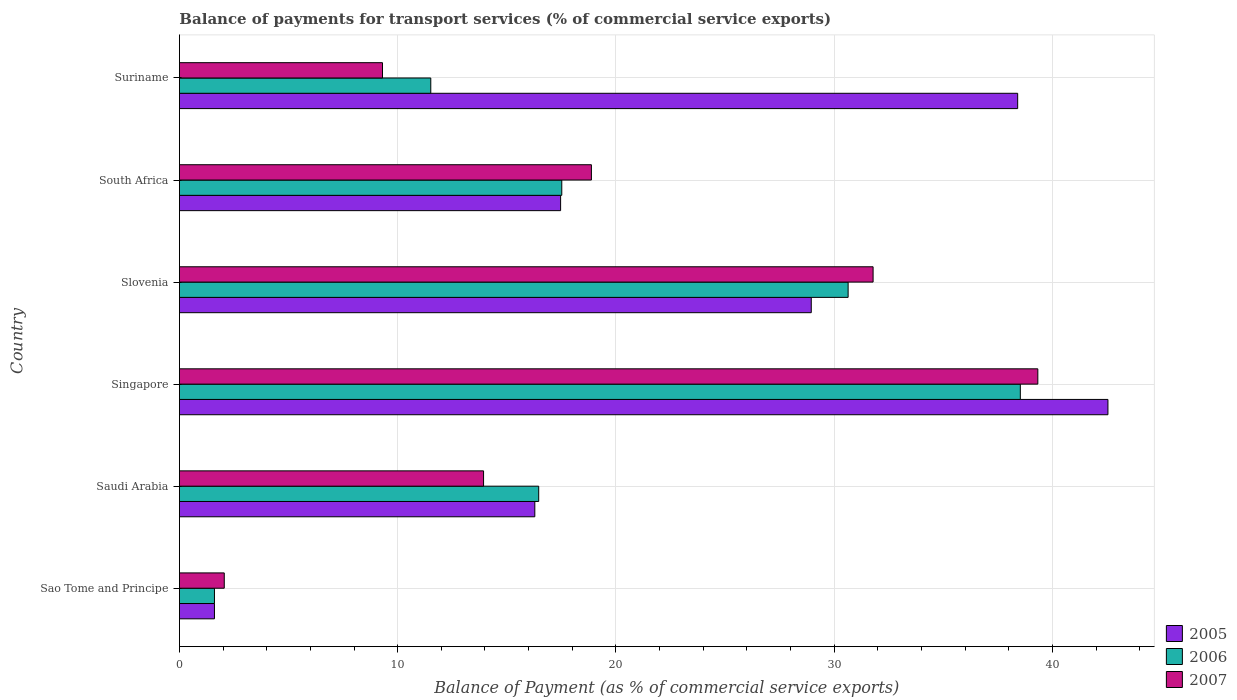How many bars are there on the 6th tick from the top?
Give a very brief answer. 3. What is the label of the 3rd group of bars from the top?
Your answer should be compact. Slovenia. What is the balance of payments for transport services in 2005 in Sao Tome and Principe?
Offer a terse response. 1.61. Across all countries, what is the maximum balance of payments for transport services in 2005?
Give a very brief answer. 42.54. Across all countries, what is the minimum balance of payments for transport services in 2005?
Offer a very short reply. 1.61. In which country was the balance of payments for transport services in 2005 maximum?
Provide a short and direct response. Singapore. In which country was the balance of payments for transport services in 2005 minimum?
Make the answer very short. Sao Tome and Principe. What is the total balance of payments for transport services in 2006 in the graph?
Provide a succinct answer. 116.27. What is the difference between the balance of payments for transport services in 2007 in South Africa and that in Suriname?
Offer a very short reply. 9.57. What is the difference between the balance of payments for transport services in 2005 in South Africa and the balance of payments for transport services in 2006 in Slovenia?
Keep it short and to the point. -13.17. What is the average balance of payments for transport services in 2007 per country?
Make the answer very short. 19.21. What is the difference between the balance of payments for transport services in 2006 and balance of payments for transport services in 2007 in Saudi Arabia?
Ensure brevity in your answer.  2.53. What is the ratio of the balance of payments for transport services in 2007 in Saudi Arabia to that in South Africa?
Provide a succinct answer. 0.74. Is the balance of payments for transport services in 2006 in Saudi Arabia less than that in Singapore?
Offer a very short reply. Yes. Is the difference between the balance of payments for transport services in 2006 in Sao Tome and Principe and Singapore greater than the difference between the balance of payments for transport services in 2007 in Sao Tome and Principe and Singapore?
Provide a succinct answer. Yes. What is the difference between the highest and the second highest balance of payments for transport services in 2005?
Your response must be concise. 4.14. What is the difference between the highest and the lowest balance of payments for transport services in 2006?
Give a very brief answer. 36.92. Are all the bars in the graph horizontal?
Keep it short and to the point. Yes. How many countries are there in the graph?
Give a very brief answer. 6. Are the values on the major ticks of X-axis written in scientific E-notation?
Your answer should be very brief. No. Does the graph contain any zero values?
Your response must be concise. No. Does the graph contain grids?
Your answer should be compact. Yes. How many legend labels are there?
Make the answer very short. 3. What is the title of the graph?
Your answer should be compact. Balance of payments for transport services (% of commercial service exports). What is the label or title of the X-axis?
Ensure brevity in your answer.  Balance of Payment (as % of commercial service exports). What is the label or title of the Y-axis?
Your answer should be very brief. Country. What is the Balance of Payment (as % of commercial service exports) of 2005 in Sao Tome and Principe?
Your response must be concise. 1.61. What is the Balance of Payment (as % of commercial service exports) in 2006 in Sao Tome and Principe?
Offer a terse response. 1.61. What is the Balance of Payment (as % of commercial service exports) of 2007 in Sao Tome and Principe?
Provide a short and direct response. 2.05. What is the Balance of Payment (as % of commercial service exports) of 2005 in Saudi Arabia?
Your answer should be compact. 16.28. What is the Balance of Payment (as % of commercial service exports) of 2006 in Saudi Arabia?
Keep it short and to the point. 16.46. What is the Balance of Payment (as % of commercial service exports) of 2007 in Saudi Arabia?
Your response must be concise. 13.94. What is the Balance of Payment (as % of commercial service exports) of 2005 in Singapore?
Provide a short and direct response. 42.54. What is the Balance of Payment (as % of commercial service exports) of 2006 in Singapore?
Provide a short and direct response. 38.53. What is the Balance of Payment (as % of commercial service exports) in 2007 in Singapore?
Make the answer very short. 39.33. What is the Balance of Payment (as % of commercial service exports) in 2005 in Slovenia?
Provide a short and direct response. 28.95. What is the Balance of Payment (as % of commercial service exports) of 2006 in Slovenia?
Keep it short and to the point. 30.64. What is the Balance of Payment (as % of commercial service exports) of 2007 in Slovenia?
Offer a very short reply. 31.78. What is the Balance of Payment (as % of commercial service exports) of 2005 in South Africa?
Give a very brief answer. 17.47. What is the Balance of Payment (as % of commercial service exports) in 2006 in South Africa?
Ensure brevity in your answer.  17.52. What is the Balance of Payment (as % of commercial service exports) in 2007 in South Africa?
Make the answer very short. 18.88. What is the Balance of Payment (as % of commercial service exports) in 2005 in Suriname?
Your answer should be very brief. 38.41. What is the Balance of Payment (as % of commercial service exports) in 2006 in Suriname?
Ensure brevity in your answer.  11.52. What is the Balance of Payment (as % of commercial service exports) of 2007 in Suriname?
Make the answer very short. 9.3. Across all countries, what is the maximum Balance of Payment (as % of commercial service exports) in 2005?
Make the answer very short. 42.54. Across all countries, what is the maximum Balance of Payment (as % of commercial service exports) of 2006?
Offer a terse response. 38.53. Across all countries, what is the maximum Balance of Payment (as % of commercial service exports) in 2007?
Keep it short and to the point. 39.33. Across all countries, what is the minimum Balance of Payment (as % of commercial service exports) in 2005?
Keep it short and to the point. 1.61. Across all countries, what is the minimum Balance of Payment (as % of commercial service exports) of 2006?
Offer a very short reply. 1.61. Across all countries, what is the minimum Balance of Payment (as % of commercial service exports) of 2007?
Your answer should be compact. 2.05. What is the total Balance of Payment (as % of commercial service exports) in 2005 in the graph?
Your answer should be very brief. 145.25. What is the total Balance of Payment (as % of commercial service exports) of 2006 in the graph?
Your response must be concise. 116.27. What is the total Balance of Payment (as % of commercial service exports) of 2007 in the graph?
Your answer should be compact. 115.28. What is the difference between the Balance of Payment (as % of commercial service exports) of 2005 in Sao Tome and Principe and that in Saudi Arabia?
Make the answer very short. -14.68. What is the difference between the Balance of Payment (as % of commercial service exports) in 2006 in Sao Tome and Principe and that in Saudi Arabia?
Keep it short and to the point. -14.86. What is the difference between the Balance of Payment (as % of commercial service exports) of 2007 in Sao Tome and Principe and that in Saudi Arabia?
Ensure brevity in your answer.  -11.88. What is the difference between the Balance of Payment (as % of commercial service exports) of 2005 in Sao Tome and Principe and that in Singapore?
Keep it short and to the point. -40.94. What is the difference between the Balance of Payment (as % of commercial service exports) in 2006 in Sao Tome and Principe and that in Singapore?
Keep it short and to the point. -36.92. What is the difference between the Balance of Payment (as % of commercial service exports) of 2007 in Sao Tome and Principe and that in Singapore?
Make the answer very short. -37.27. What is the difference between the Balance of Payment (as % of commercial service exports) of 2005 in Sao Tome and Principe and that in Slovenia?
Provide a short and direct response. -27.34. What is the difference between the Balance of Payment (as % of commercial service exports) in 2006 in Sao Tome and Principe and that in Slovenia?
Give a very brief answer. -29.03. What is the difference between the Balance of Payment (as % of commercial service exports) of 2007 in Sao Tome and Principe and that in Slovenia?
Your answer should be compact. -29.73. What is the difference between the Balance of Payment (as % of commercial service exports) in 2005 in Sao Tome and Principe and that in South Africa?
Offer a very short reply. -15.86. What is the difference between the Balance of Payment (as % of commercial service exports) in 2006 in Sao Tome and Principe and that in South Africa?
Provide a short and direct response. -15.91. What is the difference between the Balance of Payment (as % of commercial service exports) of 2007 in Sao Tome and Principe and that in South Africa?
Make the answer very short. -16.82. What is the difference between the Balance of Payment (as % of commercial service exports) of 2005 in Sao Tome and Principe and that in Suriname?
Ensure brevity in your answer.  -36.8. What is the difference between the Balance of Payment (as % of commercial service exports) of 2006 in Sao Tome and Principe and that in Suriname?
Offer a terse response. -9.91. What is the difference between the Balance of Payment (as % of commercial service exports) in 2007 in Sao Tome and Principe and that in Suriname?
Provide a succinct answer. -7.25. What is the difference between the Balance of Payment (as % of commercial service exports) in 2005 in Saudi Arabia and that in Singapore?
Keep it short and to the point. -26.26. What is the difference between the Balance of Payment (as % of commercial service exports) of 2006 in Saudi Arabia and that in Singapore?
Keep it short and to the point. -22.07. What is the difference between the Balance of Payment (as % of commercial service exports) in 2007 in Saudi Arabia and that in Singapore?
Offer a terse response. -25.39. What is the difference between the Balance of Payment (as % of commercial service exports) in 2005 in Saudi Arabia and that in Slovenia?
Provide a succinct answer. -12.67. What is the difference between the Balance of Payment (as % of commercial service exports) of 2006 in Saudi Arabia and that in Slovenia?
Provide a succinct answer. -14.18. What is the difference between the Balance of Payment (as % of commercial service exports) of 2007 in Saudi Arabia and that in Slovenia?
Make the answer very short. -17.85. What is the difference between the Balance of Payment (as % of commercial service exports) of 2005 in Saudi Arabia and that in South Africa?
Ensure brevity in your answer.  -1.18. What is the difference between the Balance of Payment (as % of commercial service exports) in 2006 in Saudi Arabia and that in South Africa?
Offer a terse response. -1.06. What is the difference between the Balance of Payment (as % of commercial service exports) of 2007 in Saudi Arabia and that in South Africa?
Your response must be concise. -4.94. What is the difference between the Balance of Payment (as % of commercial service exports) in 2005 in Saudi Arabia and that in Suriname?
Your answer should be compact. -22.12. What is the difference between the Balance of Payment (as % of commercial service exports) of 2006 in Saudi Arabia and that in Suriname?
Your answer should be very brief. 4.94. What is the difference between the Balance of Payment (as % of commercial service exports) of 2007 in Saudi Arabia and that in Suriname?
Offer a very short reply. 4.63. What is the difference between the Balance of Payment (as % of commercial service exports) in 2005 in Singapore and that in Slovenia?
Your answer should be very brief. 13.59. What is the difference between the Balance of Payment (as % of commercial service exports) of 2006 in Singapore and that in Slovenia?
Offer a very short reply. 7.89. What is the difference between the Balance of Payment (as % of commercial service exports) in 2007 in Singapore and that in Slovenia?
Your answer should be compact. 7.55. What is the difference between the Balance of Payment (as % of commercial service exports) of 2005 in Singapore and that in South Africa?
Keep it short and to the point. 25.08. What is the difference between the Balance of Payment (as % of commercial service exports) of 2006 in Singapore and that in South Africa?
Offer a terse response. 21.01. What is the difference between the Balance of Payment (as % of commercial service exports) of 2007 in Singapore and that in South Africa?
Offer a very short reply. 20.45. What is the difference between the Balance of Payment (as % of commercial service exports) in 2005 in Singapore and that in Suriname?
Your answer should be compact. 4.14. What is the difference between the Balance of Payment (as % of commercial service exports) in 2006 in Singapore and that in Suriname?
Provide a short and direct response. 27.01. What is the difference between the Balance of Payment (as % of commercial service exports) in 2007 in Singapore and that in Suriname?
Your answer should be compact. 30.02. What is the difference between the Balance of Payment (as % of commercial service exports) in 2005 in Slovenia and that in South Africa?
Give a very brief answer. 11.48. What is the difference between the Balance of Payment (as % of commercial service exports) in 2006 in Slovenia and that in South Africa?
Offer a very short reply. 13.12. What is the difference between the Balance of Payment (as % of commercial service exports) in 2007 in Slovenia and that in South Africa?
Make the answer very short. 12.91. What is the difference between the Balance of Payment (as % of commercial service exports) in 2005 in Slovenia and that in Suriname?
Ensure brevity in your answer.  -9.46. What is the difference between the Balance of Payment (as % of commercial service exports) in 2006 in Slovenia and that in Suriname?
Keep it short and to the point. 19.12. What is the difference between the Balance of Payment (as % of commercial service exports) in 2007 in Slovenia and that in Suriname?
Provide a short and direct response. 22.48. What is the difference between the Balance of Payment (as % of commercial service exports) of 2005 in South Africa and that in Suriname?
Offer a very short reply. -20.94. What is the difference between the Balance of Payment (as % of commercial service exports) in 2006 in South Africa and that in Suriname?
Your answer should be compact. 6. What is the difference between the Balance of Payment (as % of commercial service exports) in 2007 in South Africa and that in Suriname?
Make the answer very short. 9.57. What is the difference between the Balance of Payment (as % of commercial service exports) of 2005 in Sao Tome and Principe and the Balance of Payment (as % of commercial service exports) of 2006 in Saudi Arabia?
Ensure brevity in your answer.  -14.86. What is the difference between the Balance of Payment (as % of commercial service exports) of 2005 in Sao Tome and Principe and the Balance of Payment (as % of commercial service exports) of 2007 in Saudi Arabia?
Provide a short and direct response. -12.33. What is the difference between the Balance of Payment (as % of commercial service exports) of 2006 in Sao Tome and Principe and the Balance of Payment (as % of commercial service exports) of 2007 in Saudi Arabia?
Your answer should be compact. -12.33. What is the difference between the Balance of Payment (as % of commercial service exports) of 2005 in Sao Tome and Principe and the Balance of Payment (as % of commercial service exports) of 2006 in Singapore?
Give a very brief answer. -36.92. What is the difference between the Balance of Payment (as % of commercial service exports) in 2005 in Sao Tome and Principe and the Balance of Payment (as % of commercial service exports) in 2007 in Singapore?
Your answer should be compact. -37.72. What is the difference between the Balance of Payment (as % of commercial service exports) in 2006 in Sao Tome and Principe and the Balance of Payment (as % of commercial service exports) in 2007 in Singapore?
Offer a very short reply. -37.72. What is the difference between the Balance of Payment (as % of commercial service exports) of 2005 in Sao Tome and Principe and the Balance of Payment (as % of commercial service exports) of 2006 in Slovenia?
Make the answer very short. -29.03. What is the difference between the Balance of Payment (as % of commercial service exports) of 2005 in Sao Tome and Principe and the Balance of Payment (as % of commercial service exports) of 2007 in Slovenia?
Keep it short and to the point. -30.18. What is the difference between the Balance of Payment (as % of commercial service exports) of 2006 in Sao Tome and Principe and the Balance of Payment (as % of commercial service exports) of 2007 in Slovenia?
Offer a very short reply. -30.18. What is the difference between the Balance of Payment (as % of commercial service exports) in 2005 in Sao Tome and Principe and the Balance of Payment (as % of commercial service exports) in 2006 in South Africa?
Offer a very short reply. -15.91. What is the difference between the Balance of Payment (as % of commercial service exports) in 2005 in Sao Tome and Principe and the Balance of Payment (as % of commercial service exports) in 2007 in South Africa?
Your response must be concise. -17.27. What is the difference between the Balance of Payment (as % of commercial service exports) in 2006 in Sao Tome and Principe and the Balance of Payment (as % of commercial service exports) in 2007 in South Africa?
Your answer should be compact. -17.27. What is the difference between the Balance of Payment (as % of commercial service exports) of 2005 in Sao Tome and Principe and the Balance of Payment (as % of commercial service exports) of 2006 in Suriname?
Offer a very short reply. -9.91. What is the difference between the Balance of Payment (as % of commercial service exports) of 2005 in Sao Tome and Principe and the Balance of Payment (as % of commercial service exports) of 2007 in Suriname?
Provide a succinct answer. -7.7. What is the difference between the Balance of Payment (as % of commercial service exports) of 2006 in Sao Tome and Principe and the Balance of Payment (as % of commercial service exports) of 2007 in Suriname?
Provide a succinct answer. -7.7. What is the difference between the Balance of Payment (as % of commercial service exports) in 2005 in Saudi Arabia and the Balance of Payment (as % of commercial service exports) in 2006 in Singapore?
Offer a very short reply. -22.25. What is the difference between the Balance of Payment (as % of commercial service exports) of 2005 in Saudi Arabia and the Balance of Payment (as % of commercial service exports) of 2007 in Singapore?
Provide a succinct answer. -23.05. What is the difference between the Balance of Payment (as % of commercial service exports) in 2006 in Saudi Arabia and the Balance of Payment (as % of commercial service exports) in 2007 in Singapore?
Offer a terse response. -22.87. What is the difference between the Balance of Payment (as % of commercial service exports) of 2005 in Saudi Arabia and the Balance of Payment (as % of commercial service exports) of 2006 in Slovenia?
Your answer should be very brief. -14.35. What is the difference between the Balance of Payment (as % of commercial service exports) of 2005 in Saudi Arabia and the Balance of Payment (as % of commercial service exports) of 2007 in Slovenia?
Keep it short and to the point. -15.5. What is the difference between the Balance of Payment (as % of commercial service exports) of 2006 in Saudi Arabia and the Balance of Payment (as % of commercial service exports) of 2007 in Slovenia?
Ensure brevity in your answer.  -15.32. What is the difference between the Balance of Payment (as % of commercial service exports) of 2005 in Saudi Arabia and the Balance of Payment (as % of commercial service exports) of 2006 in South Africa?
Your answer should be compact. -1.24. What is the difference between the Balance of Payment (as % of commercial service exports) in 2005 in Saudi Arabia and the Balance of Payment (as % of commercial service exports) in 2007 in South Africa?
Offer a very short reply. -2.59. What is the difference between the Balance of Payment (as % of commercial service exports) of 2006 in Saudi Arabia and the Balance of Payment (as % of commercial service exports) of 2007 in South Africa?
Your answer should be very brief. -2.41. What is the difference between the Balance of Payment (as % of commercial service exports) in 2005 in Saudi Arabia and the Balance of Payment (as % of commercial service exports) in 2006 in Suriname?
Make the answer very short. 4.77. What is the difference between the Balance of Payment (as % of commercial service exports) in 2005 in Saudi Arabia and the Balance of Payment (as % of commercial service exports) in 2007 in Suriname?
Give a very brief answer. 6.98. What is the difference between the Balance of Payment (as % of commercial service exports) in 2006 in Saudi Arabia and the Balance of Payment (as % of commercial service exports) in 2007 in Suriname?
Your response must be concise. 7.16. What is the difference between the Balance of Payment (as % of commercial service exports) in 2005 in Singapore and the Balance of Payment (as % of commercial service exports) in 2006 in Slovenia?
Your response must be concise. 11.9. What is the difference between the Balance of Payment (as % of commercial service exports) in 2005 in Singapore and the Balance of Payment (as % of commercial service exports) in 2007 in Slovenia?
Give a very brief answer. 10.76. What is the difference between the Balance of Payment (as % of commercial service exports) of 2006 in Singapore and the Balance of Payment (as % of commercial service exports) of 2007 in Slovenia?
Ensure brevity in your answer.  6.75. What is the difference between the Balance of Payment (as % of commercial service exports) of 2005 in Singapore and the Balance of Payment (as % of commercial service exports) of 2006 in South Africa?
Your answer should be very brief. 25.02. What is the difference between the Balance of Payment (as % of commercial service exports) of 2005 in Singapore and the Balance of Payment (as % of commercial service exports) of 2007 in South Africa?
Your response must be concise. 23.67. What is the difference between the Balance of Payment (as % of commercial service exports) in 2006 in Singapore and the Balance of Payment (as % of commercial service exports) in 2007 in South Africa?
Make the answer very short. 19.65. What is the difference between the Balance of Payment (as % of commercial service exports) of 2005 in Singapore and the Balance of Payment (as % of commercial service exports) of 2006 in Suriname?
Give a very brief answer. 31.03. What is the difference between the Balance of Payment (as % of commercial service exports) of 2005 in Singapore and the Balance of Payment (as % of commercial service exports) of 2007 in Suriname?
Make the answer very short. 33.24. What is the difference between the Balance of Payment (as % of commercial service exports) of 2006 in Singapore and the Balance of Payment (as % of commercial service exports) of 2007 in Suriname?
Make the answer very short. 29.22. What is the difference between the Balance of Payment (as % of commercial service exports) of 2005 in Slovenia and the Balance of Payment (as % of commercial service exports) of 2006 in South Africa?
Your answer should be compact. 11.43. What is the difference between the Balance of Payment (as % of commercial service exports) of 2005 in Slovenia and the Balance of Payment (as % of commercial service exports) of 2007 in South Africa?
Your response must be concise. 10.07. What is the difference between the Balance of Payment (as % of commercial service exports) of 2006 in Slovenia and the Balance of Payment (as % of commercial service exports) of 2007 in South Africa?
Your answer should be very brief. 11.76. What is the difference between the Balance of Payment (as % of commercial service exports) in 2005 in Slovenia and the Balance of Payment (as % of commercial service exports) in 2006 in Suriname?
Keep it short and to the point. 17.43. What is the difference between the Balance of Payment (as % of commercial service exports) in 2005 in Slovenia and the Balance of Payment (as % of commercial service exports) in 2007 in Suriname?
Provide a succinct answer. 19.64. What is the difference between the Balance of Payment (as % of commercial service exports) of 2006 in Slovenia and the Balance of Payment (as % of commercial service exports) of 2007 in Suriname?
Your answer should be compact. 21.33. What is the difference between the Balance of Payment (as % of commercial service exports) of 2005 in South Africa and the Balance of Payment (as % of commercial service exports) of 2006 in Suriname?
Offer a terse response. 5.95. What is the difference between the Balance of Payment (as % of commercial service exports) in 2005 in South Africa and the Balance of Payment (as % of commercial service exports) in 2007 in Suriname?
Ensure brevity in your answer.  8.16. What is the difference between the Balance of Payment (as % of commercial service exports) in 2006 in South Africa and the Balance of Payment (as % of commercial service exports) in 2007 in Suriname?
Keep it short and to the point. 8.21. What is the average Balance of Payment (as % of commercial service exports) of 2005 per country?
Keep it short and to the point. 24.21. What is the average Balance of Payment (as % of commercial service exports) of 2006 per country?
Offer a very short reply. 19.38. What is the average Balance of Payment (as % of commercial service exports) of 2007 per country?
Provide a short and direct response. 19.21. What is the difference between the Balance of Payment (as % of commercial service exports) in 2005 and Balance of Payment (as % of commercial service exports) in 2007 in Sao Tome and Principe?
Ensure brevity in your answer.  -0.45. What is the difference between the Balance of Payment (as % of commercial service exports) of 2006 and Balance of Payment (as % of commercial service exports) of 2007 in Sao Tome and Principe?
Offer a terse response. -0.45. What is the difference between the Balance of Payment (as % of commercial service exports) of 2005 and Balance of Payment (as % of commercial service exports) of 2006 in Saudi Arabia?
Make the answer very short. -0.18. What is the difference between the Balance of Payment (as % of commercial service exports) in 2005 and Balance of Payment (as % of commercial service exports) in 2007 in Saudi Arabia?
Provide a succinct answer. 2.35. What is the difference between the Balance of Payment (as % of commercial service exports) of 2006 and Balance of Payment (as % of commercial service exports) of 2007 in Saudi Arabia?
Your answer should be very brief. 2.53. What is the difference between the Balance of Payment (as % of commercial service exports) of 2005 and Balance of Payment (as % of commercial service exports) of 2006 in Singapore?
Provide a succinct answer. 4.01. What is the difference between the Balance of Payment (as % of commercial service exports) in 2005 and Balance of Payment (as % of commercial service exports) in 2007 in Singapore?
Offer a very short reply. 3.21. What is the difference between the Balance of Payment (as % of commercial service exports) in 2006 and Balance of Payment (as % of commercial service exports) in 2007 in Singapore?
Make the answer very short. -0.8. What is the difference between the Balance of Payment (as % of commercial service exports) of 2005 and Balance of Payment (as % of commercial service exports) of 2006 in Slovenia?
Ensure brevity in your answer.  -1.69. What is the difference between the Balance of Payment (as % of commercial service exports) of 2005 and Balance of Payment (as % of commercial service exports) of 2007 in Slovenia?
Your response must be concise. -2.83. What is the difference between the Balance of Payment (as % of commercial service exports) in 2006 and Balance of Payment (as % of commercial service exports) in 2007 in Slovenia?
Your response must be concise. -1.14. What is the difference between the Balance of Payment (as % of commercial service exports) of 2005 and Balance of Payment (as % of commercial service exports) of 2006 in South Africa?
Offer a very short reply. -0.05. What is the difference between the Balance of Payment (as % of commercial service exports) of 2005 and Balance of Payment (as % of commercial service exports) of 2007 in South Africa?
Your response must be concise. -1.41. What is the difference between the Balance of Payment (as % of commercial service exports) in 2006 and Balance of Payment (as % of commercial service exports) in 2007 in South Africa?
Provide a short and direct response. -1.36. What is the difference between the Balance of Payment (as % of commercial service exports) in 2005 and Balance of Payment (as % of commercial service exports) in 2006 in Suriname?
Make the answer very short. 26.89. What is the difference between the Balance of Payment (as % of commercial service exports) of 2005 and Balance of Payment (as % of commercial service exports) of 2007 in Suriname?
Ensure brevity in your answer.  29.1. What is the difference between the Balance of Payment (as % of commercial service exports) of 2006 and Balance of Payment (as % of commercial service exports) of 2007 in Suriname?
Offer a terse response. 2.21. What is the ratio of the Balance of Payment (as % of commercial service exports) of 2005 in Sao Tome and Principe to that in Saudi Arabia?
Offer a terse response. 0.1. What is the ratio of the Balance of Payment (as % of commercial service exports) in 2006 in Sao Tome and Principe to that in Saudi Arabia?
Provide a short and direct response. 0.1. What is the ratio of the Balance of Payment (as % of commercial service exports) of 2007 in Sao Tome and Principe to that in Saudi Arabia?
Your response must be concise. 0.15. What is the ratio of the Balance of Payment (as % of commercial service exports) in 2005 in Sao Tome and Principe to that in Singapore?
Your answer should be compact. 0.04. What is the ratio of the Balance of Payment (as % of commercial service exports) of 2006 in Sao Tome and Principe to that in Singapore?
Give a very brief answer. 0.04. What is the ratio of the Balance of Payment (as % of commercial service exports) of 2007 in Sao Tome and Principe to that in Singapore?
Make the answer very short. 0.05. What is the ratio of the Balance of Payment (as % of commercial service exports) in 2005 in Sao Tome and Principe to that in Slovenia?
Provide a short and direct response. 0.06. What is the ratio of the Balance of Payment (as % of commercial service exports) of 2006 in Sao Tome and Principe to that in Slovenia?
Keep it short and to the point. 0.05. What is the ratio of the Balance of Payment (as % of commercial service exports) in 2007 in Sao Tome and Principe to that in Slovenia?
Ensure brevity in your answer.  0.06. What is the ratio of the Balance of Payment (as % of commercial service exports) of 2005 in Sao Tome and Principe to that in South Africa?
Make the answer very short. 0.09. What is the ratio of the Balance of Payment (as % of commercial service exports) in 2006 in Sao Tome and Principe to that in South Africa?
Offer a terse response. 0.09. What is the ratio of the Balance of Payment (as % of commercial service exports) in 2007 in Sao Tome and Principe to that in South Africa?
Provide a short and direct response. 0.11. What is the ratio of the Balance of Payment (as % of commercial service exports) of 2005 in Sao Tome and Principe to that in Suriname?
Your response must be concise. 0.04. What is the ratio of the Balance of Payment (as % of commercial service exports) of 2006 in Sao Tome and Principe to that in Suriname?
Provide a short and direct response. 0.14. What is the ratio of the Balance of Payment (as % of commercial service exports) of 2007 in Sao Tome and Principe to that in Suriname?
Your answer should be compact. 0.22. What is the ratio of the Balance of Payment (as % of commercial service exports) in 2005 in Saudi Arabia to that in Singapore?
Your answer should be compact. 0.38. What is the ratio of the Balance of Payment (as % of commercial service exports) in 2006 in Saudi Arabia to that in Singapore?
Offer a terse response. 0.43. What is the ratio of the Balance of Payment (as % of commercial service exports) in 2007 in Saudi Arabia to that in Singapore?
Offer a very short reply. 0.35. What is the ratio of the Balance of Payment (as % of commercial service exports) in 2005 in Saudi Arabia to that in Slovenia?
Your response must be concise. 0.56. What is the ratio of the Balance of Payment (as % of commercial service exports) of 2006 in Saudi Arabia to that in Slovenia?
Your response must be concise. 0.54. What is the ratio of the Balance of Payment (as % of commercial service exports) of 2007 in Saudi Arabia to that in Slovenia?
Give a very brief answer. 0.44. What is the ratio of the Balance of Payment (as % of commercial service exports) in 2005 in Saudi Arabia to that in South Africa?
Ensure brevity in your answer.  0.93. What is the ratio of the Balance of Payment (as % of commercial service exports) in 2006 in Saudi Arabia to that in South Africa?
Your answer should be very brief. 0.94. What is the ratio of the Balance of Payment (as % of commercial service exports) in 2007 in Saudi Arabia to that in South Africa?
Ensure brevity in your answer.  0.74. What is the ratio of the Balance of Payment (as % of commercial service exports) in 2005 in Saudi Arabia to that in Suriname?
Ensure brevity in your answer.  0.42. What is the ratio of the Balance of Payment (as % of commercial service exports) of 2006 in Saudi Arabia to that in Suriname?
Give a very brief answer. 1.43. What is the ratio of the Balance of Payment (as % of commercial service exports) in 2007 in Saudi Arabia to that in Suriname?
Your answer should be compact. 1.5. What is the ratio of the Balance of Payment (as % of commercial service exports) of 2005 in Singapore to that in Slovenia?
Your answer should be compact. 1.47. What is the ratio of the Balance of Payment (as % of commercial service exports) of 2006 in Singapore to that in Slovenia?
Provide a short and direct response. 1.26. What is the ratio of the Balance of Payment (as % of commercial service exports) in 2007 in Singapore to that in Slovenia?
Your answer should be compact. 1.24. What is the ratio of the Balance of Payment (as % of commercial service exports) of 2005 in Singapore to that in South Africa?
Provide a short and direct response. 2.44. What is the ratio of the Balance of Payment (as % of commercial service exports) of 2006 in Singapore to that in South Africa?
Keep it short and to the point. 2.2. What is the ratio of the Balance of Payment (as % of commercial service exports) of 2007 in Singapore to that in South Africa?
Offer a very short reply. 2.08. What is the ratio of the Balance of Payment (as % of commercial service exports) of 2005 in Singapore to that in Suriname?
Your answer should be very brief. 1.11. What is the ratio of the Balance of Payment (as % of commercial service exports) of 2006 in Singapore to that in Suriname?
Make the answer very short. 3.35. What is the ratio of the Balance of Payment (as % of commercial service exports) of 2007 in Singapore to that in Suriname?
Offer a very short reply. 4.23. What is the ratio of the Balance of Payment (as % of commercial service exports) in 2005 in Slovenia to that in South Africa?
Ensure brevity in your answer.  1.66. What is the ratio of the Balance of Payment (as % of commercial service exports) in 2006 in Slovenia to that in South Africa?
Offer a terse response. 1.75. What is the ratio of the Balance of Payment (as % of commercial service exports) of 2007 in Slovenia to that in South Africa?
Provide a succinct answer. 1.68. What is the ratio of the Balance of Payment (as % of commercial service exports) of 2005 in Slovenia to that in Suriname?
Your response must be concise. 0.75. What is the ratio of the Balance of Payment (as % of commercial service exports) in 2006 in Slovenia to that in Suriname?
Provide a short and direct response. 2.66. What is the ratio of the Balance of Payment (as % of commercial service exports) in 2007 in Slovenia to that in Suriname?
Give a very brief answer. 3.42. What is the ratio of the Balance of Payment (as % of commercial service exports) of 2005 in South Africa to that in Suriname?
Provide a succinct answer. 0.45. What is the ratio of the Balance of Payment (as % of commercial service exports) of 2006 in South Africa to that in Suriname?
Your answer should be compact. 1.52. What is the ratio of the Balance of Payment (as % of commercial service exports) in 2007 in South Africa to that in Suriname?
Give a very brief answer. 2.03. What is the difference between the highest and the second highest Balance of Payment (as % of commercial service exports) in 2005?
Ensure brevity in your answer.  4.14. What is the difference between the highest and the second highest Balance of Payment (as % of commercial service exports) in 2006?
Give a very brief answer. 7.89. What is the difference between the highest and the second highest Balance of Payment (as % of commercial service exports) of 2007?
Make the answer very short. 7.55. What is the difference between the highest and the lowest Balance of Payment (as % of commercial service exports) in 2005?
Your answer should be compact. 40.94. What is the difference between the highest and the lowest Balance of Payment (as % of commercial service exports) of 2006?
Keep it short and to the point. 36.92. What is the difference between the highest and the lowest Balance of Payment (as % of commercial service exports) of 2007?
Your answer should be very brief. 37.27. 